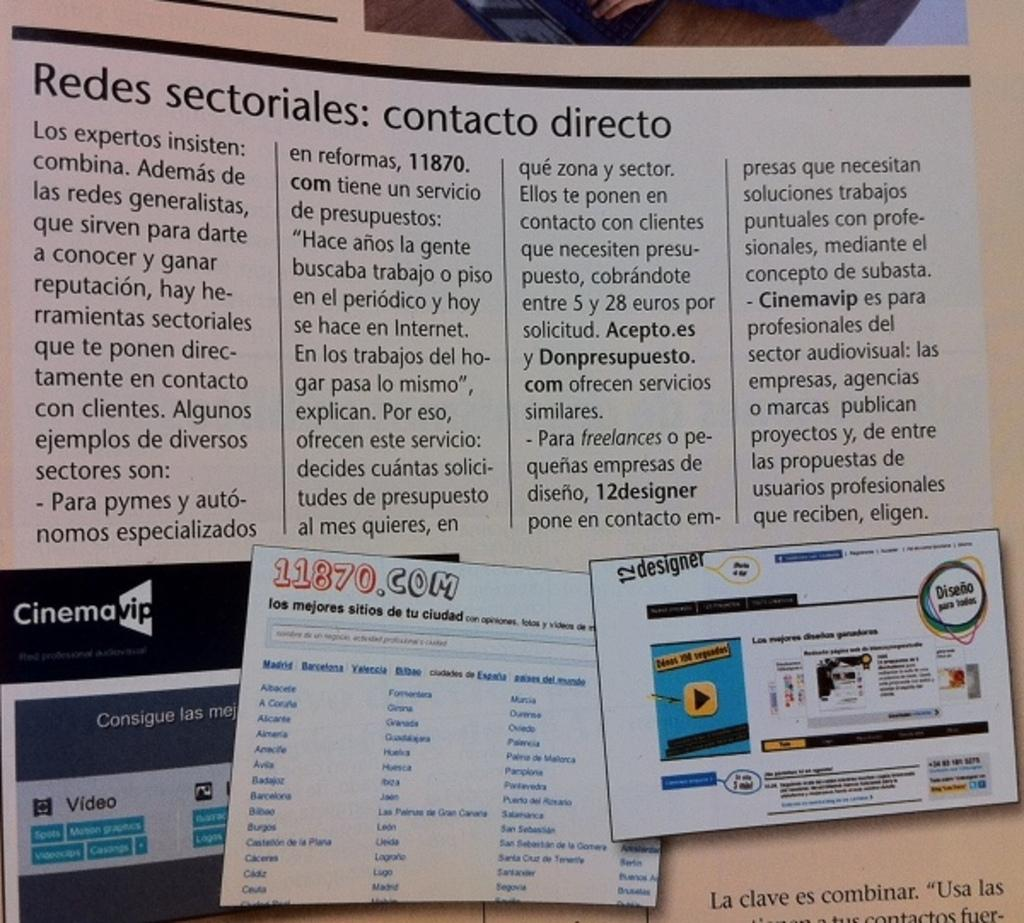<image>
Write a terse but informative summary of the picture. A 11870.com flyer is pinned to a board with various other flyers. 